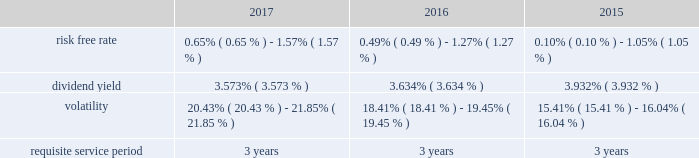Performance based restricted stock awards is generally recognized using the accelerated amortization method with each vesting tranche valued as a separate award , with a separate vesting date , consistent with the estimated value of the award at each period end .
Additionally , compensation expense is adjusted for actual forfeitures for all awards in the period that the award was forfeited .
Compensation expense for stock options is generally recognized on a straight-line basis over the requisite service period .
Maa presents stock compensation expense in the consolidated statements of operations in "general and administrative expenses" .
Effective january 1 , 2017 , the company adopted asu 2016-09 , improvements to employee share- based payment accounting , which allows employers to make a policy election to account for forfeitures as they occur .
The company elected this option using the modified retrospective transition method , with a cumulative effect adjustment to retained earnings , and there was no material effect on the consolidated financial position or results of operations taken as a whole resulting from the reversal of previously estimated forfeitures .
Total compensation expense under the stock plan was approximately $ 10.8 million , $ 12.2 million and $ 6.9 million for the years ended december 31 , 2017 , 2016 and 2015 , respectively .
Of these amounts , total compensation expense capitalized was approximately $ 0.2 million , $ 0.7 million and $ 0.7 million for the years ended december 31 , 2017 , 2016 and 2015 , respectively .
As of december 31 , 2017 , the total unrecognized compensation expense was approximately $ 14.1 million .
This cost is expected to be recognized over the remaining weighted average period of 1.2 years .
Total cash paid for the settlement of plan shares totaled $ 4.8 million , $ 2.0 million and $ 1.0 million for the years ended december 31 , 2017 , 2016 and 2015 , respectively .
Information concerning grants under the stock plan is listed below .
Restricted stock in general , restricted stock is earned based on either a service condition , performance condition , or market condition , or a combination thereof , and generally vests ratably over a period from 1 year to 5 years .
Service based awards are earned when the employee remains employed over the requisite service period and are valued on the grant date based upon the market price of maa common stock on the date of grant .
Market based awards are earned when maa reaches a specified stock price or specified return on the stock price ( price appreciation plus dividends ) and are valued on the grant date using a monte carlo simulation .
Performance based awards are earned when maa reaches certain operational goals such as funds from operations , or ffo , targets and are valued based upon the market price of maa common stock on the date of grant as well as the probability of reaching the stated targets .
Maa remeasures the fair value of the performance based awards each balance sheet date with adjustments made on a cumulative basis until the award is settled and the final compensation is known .
The weighted average grant date fair value per share of restricted stock awards granted during the years ended december 31 , 2017 , 2016 and 2015 , was $ 84.53 , $ 73.20 and $ 68.35 , respectively .
The following is a summary of the key assumptions used in the valuation calculations for market based awards granted during the years ended december 31 , 2017 , 2016 and 2015: .
The risk free rate was based on a zero coupon risk-free rate .
The minimum risk free rate was based on a period of 0.25 years for the years ended december 31 , 2017 , 2016 and 2015 .
The maximum risk free rate was based on a period of 3 years for the years ended december 31 , 2017 , 2016 and 2015 .
The dividend yield was based on the closing stock price of maa stock on the date of grant .
Volatility for maa was obtained by using a blend of both historical and implied volatility calculations .
Historical volatility was based on the standard deviation of daily total continuous returns , and implied volatility was based on the trailing month average of daily implied volatilities interpolating between the volatilities implied by stock call option contracts that were closest to the terms shown and closest to the money .
The minimum volatility was based on a period of 3 years , 2 years and 1 year for the years ended december 31 , 2017 , 2016 and 2015 , respectively .
The maximum volatility was based on a period of 1 year , 1 year and 2 years for the years ended december 31 , 2017 , 2016 and 2015 , respectively .
The requisite service period is based on the criteria for the separate programs according to the vesting schedule. .
What is the average volatility for 2017? 
Rationale: it is the sum of both percentages of 2017 divided by two .
Computations: ((21.85% + 20.43%) / 2)
Answer: 0.2114. 